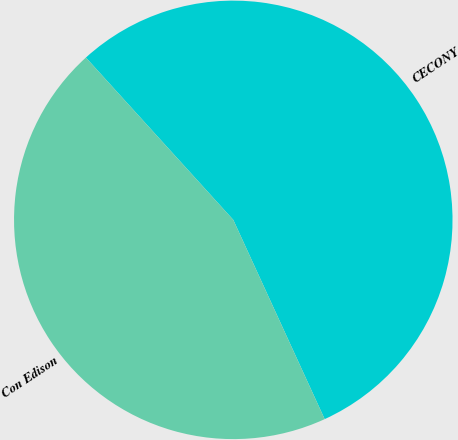Convert chart. <chart><loc_0><loc_0><loc_500><loc_500><pie_chart><fcel>CECONY<fcel>Con Edison<nl><fcel>54.89%<fcel>45.11%<nl></chart> 